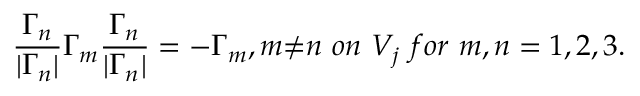<formula> <loc_0><loc_0><loc_500><loc_500>\frac { { \Gamma } _ { n } } { | { \Gamma } _ { n } | } { \Gamma } _ { m } \frac { { \Gamma } _ { n } } { | { \Gamma } _ { n } | } = - { \Gamma } _ { m } , m { \neq } n o n V _ { j } f o r m , n = 1 , 2 , 3 .</formula> 